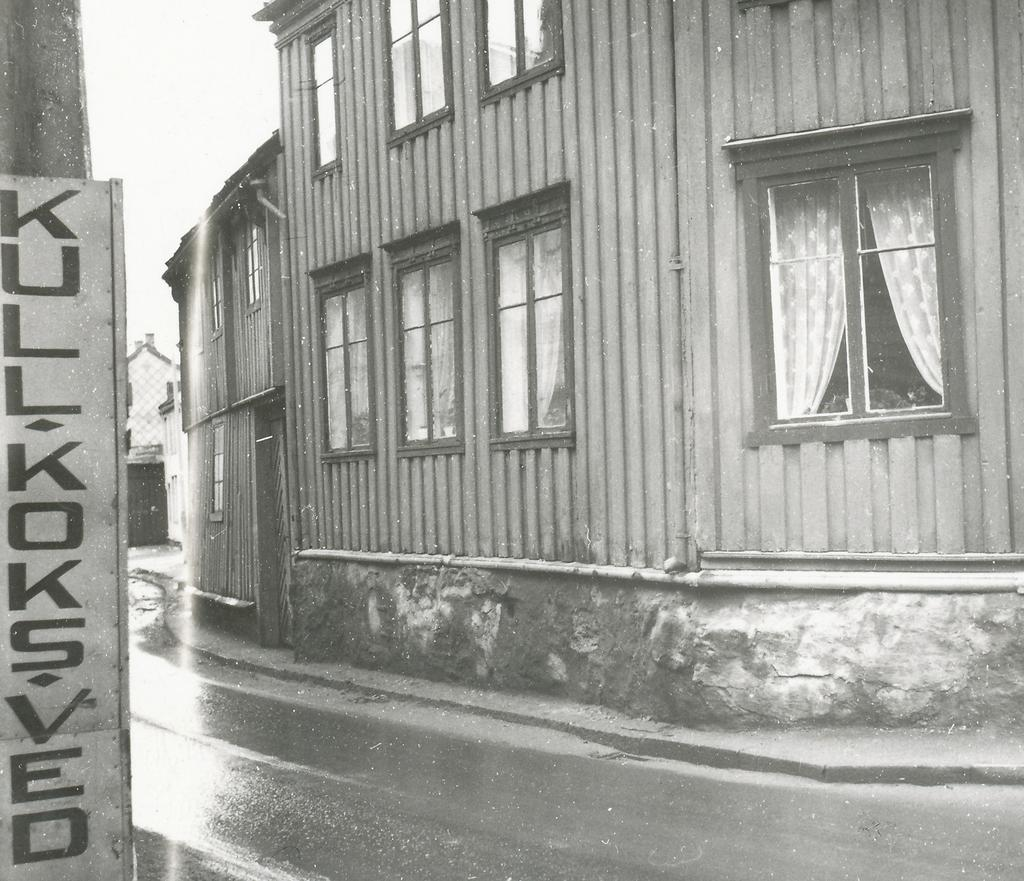What is the main feature of the image? There is a road in the image. What type of structures can be seen near the road? There are buildings with windows in the image. What is located on the left side of the image? There is a pole on the left side of the image. What type of song can be heard playing in the background of the image? There is no indication of any sound or song in the image, as it is a still photograph. 